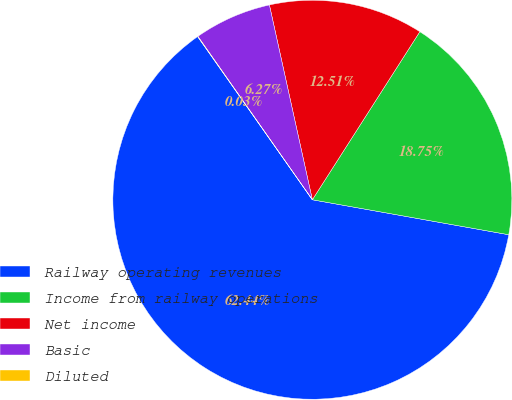Convert chart. <chart><loc_0><loc_0><loc_500><loc_500><pie_chart><fcel>Railway operating revenues<fcel>Income from railway operations<fcel>Net income<fcel>Basic<fcel>Diluted<nl><fcel>62.44%<fcel>18.75%<fcel>12.51%<fcel>6.27%<fcel>0.03%<nl></chart> 